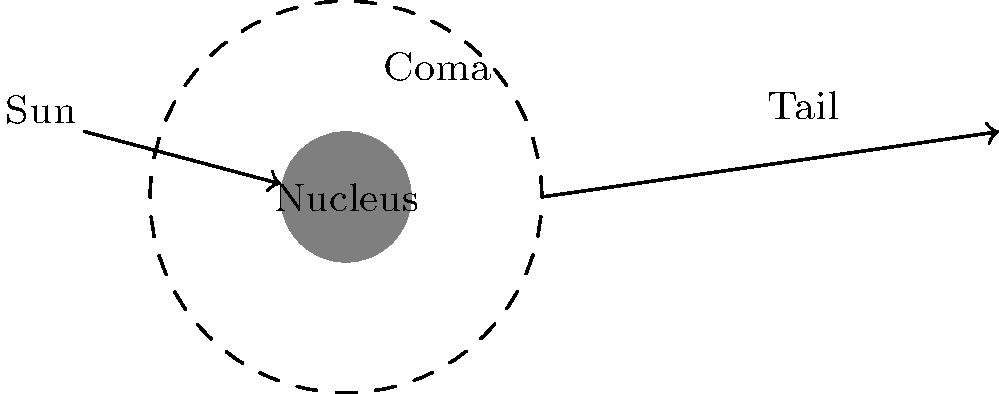In the structure of a comet, which part is often described as a "fuzzy atmosphere" surrounding the central core, similar to how Carly Rae Jepsen's catchy melodies surround the core lyrics of her songs? To answer this question, let's break down the structure of a comet:

1. Nucleus: This is the solid, central core of the comet, composed of ice, dust, and rocky particles. It's like the main lyrics or message in a Carly Rae Jepsen song.

2. Coma: This is the fuzzy, cloud-like atmosphere surrounding the nucleus. It forms when the comet approaches the sun, and the heat causes the icy materials in the nucleus to sublimate (change directly from solid to gas). This creates a cloud of gas and dust around the nucleus. The coma is similar to how catchy melodies and harmonies surround and enhance the core lyrics in Jepsen's songs.

3. Tail: As the comet moves closer to the sun, solar radiation and solar wind push some of the coma material away from the nucleus, forming one or two tails. This isn't relevant to the question but completes the comet structure.

The part described as a "fuzzy atmosphere" surrounding the central core is the coma. It's the most visible part of the comet when viewed from Earth, just as catchy melodies are often the most memorable part of a pop song.
Answer: Coma 